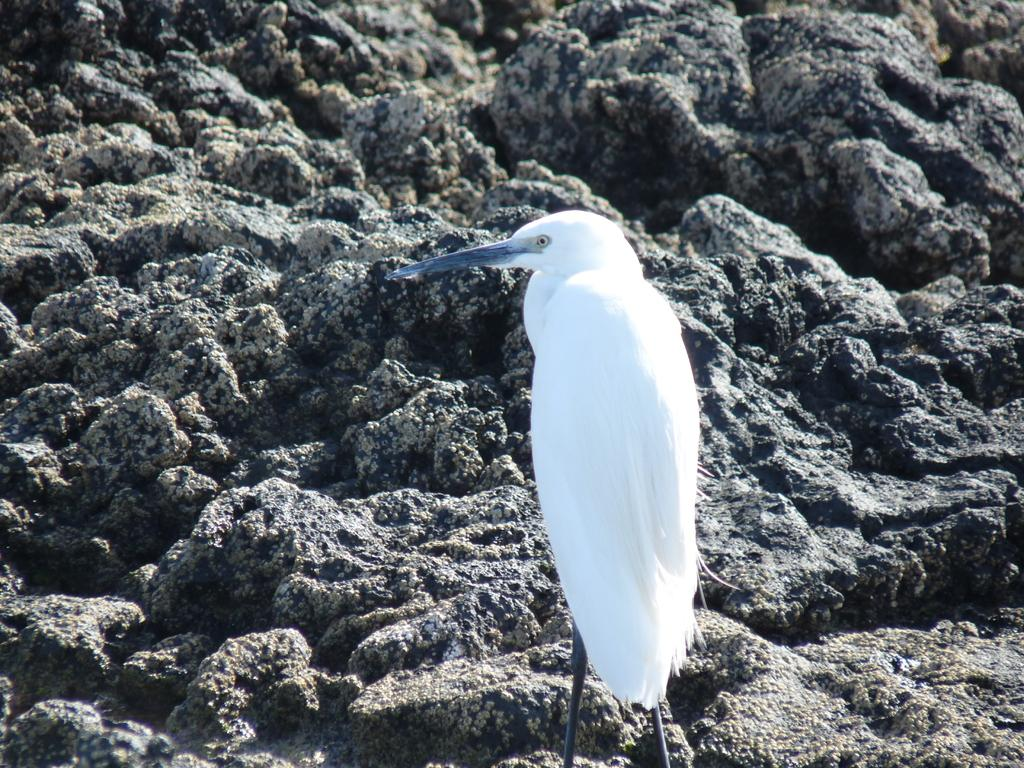What type of animal is in the image? There is a white bird in the image. What is the bird doing in the image? The bird is standing in the image. What can be seen in the background of the image? There is a rock in the background of the image. How many women are present in the image? There are no women present in the image; it features a white bird standing near a rock. What type of kettle can be seen in the image? There is no kettle present in the image. 